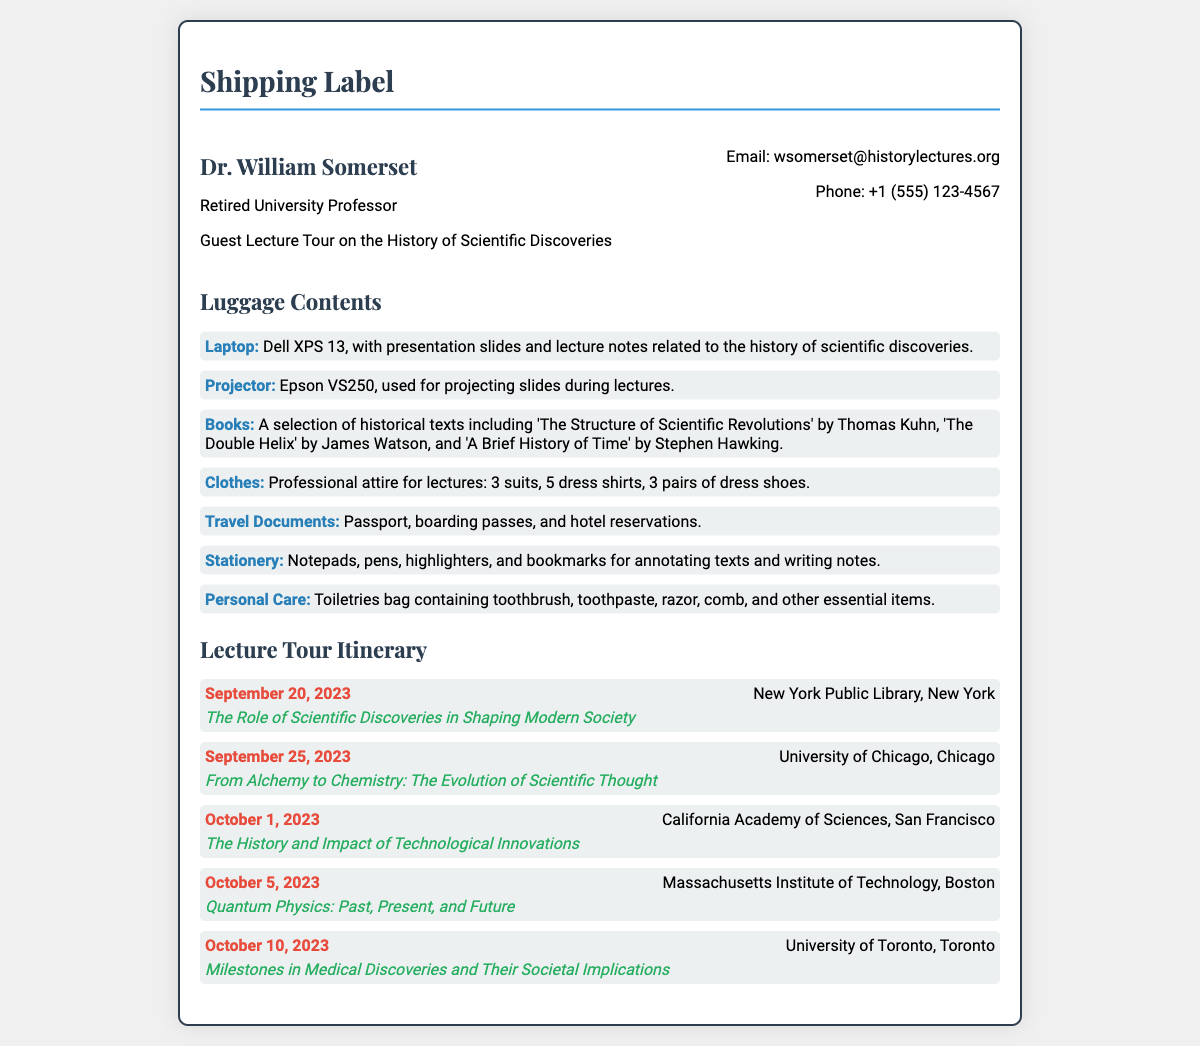What is the name of the person associated with this shipping label? The document lists Dr. William Somerset as the owner of the shipping label.
Answer: Dr. William Somerset What is the email address provided? The email address for contacting Dr. William Somerset is stated in the document.
Answer: wsomerset@historylectures.org How many suits are packed for the lecture tour? The clothing section mentions the number of suits included in the luggage contents.
Answer: 3 suits What is the date of the lecture at the University of Toronto? The document specifies the date of the lecture at the University of Toronto.
Answer: October 10, 2023 What type of projector is listed in the luggage contents? The luggage contents section mentions the specific model of the projector being taken on the tour.
Answer: Epson VS250 Which book by James Watson is included in the luggage? One of the books listed in the luggage contents is specified to be by James Watson.
Answer: The Double Helix How many dress shirts are included in the luggage contents? The luggage contents detail the number of dress shirts packed for the tour.
Answer: 5 dress shirts What is the main topic of the lecture on October 5, 2023? The itinerary lists the specific topic of the lecture at MIT on October 5, 2023.
Answer: Quantum Physics: Past, Present, and Future What type of items are mentioned under the personal care category? The personal care section of the luggage contents describes the included items.
Answer: Toiletries bag containing toothbrush, toothpaste, razor, comb, and other essential items 